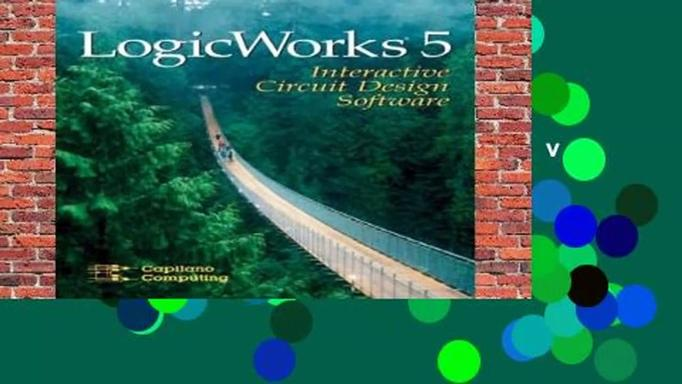How does using LogicWorks 5 benefit students in learning electronics? Using LogicWorks 5 significantly enhances learning for students by allowing them to visually construct and manipulate circuits, witness real-time simulation of digital logic behavior, and engage with practical, hands-on experiences that bridge theoretical knowledge with real-world applications. This kind of interactive learning is invaluable for grasping complex concepts in electronics. 